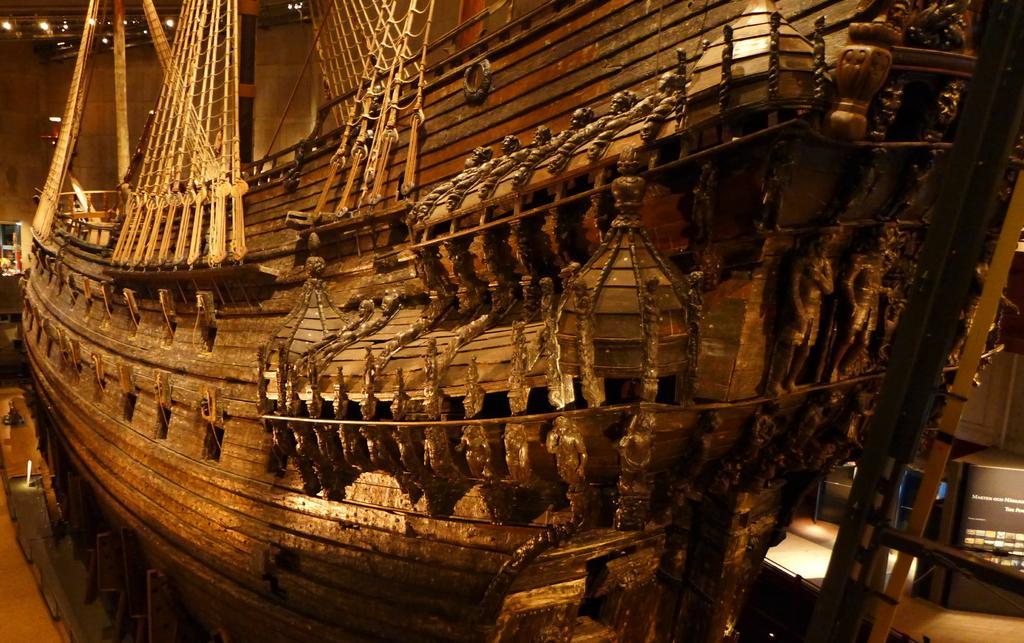Please provide a concise description of this image. In this image we can see wooden ship. In the background there is a wall and lights. 